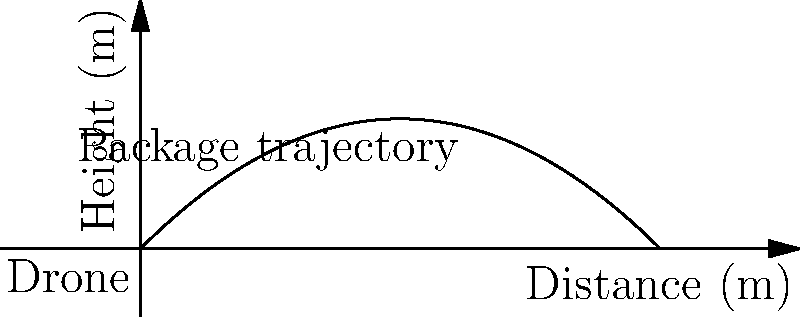A delivery drone launches a package with an initial velocity of 20 m/s at an angle of 45° above the horizontal. Assuming air resistance is negligible, what is the maximum height reached by the package during its flight? To find the maximum height reached by the package, we can follow these steps:

1. Identify the relevant equations:
   - Vertical motion: $y = v_0 \sin(\theta) t - \frac{1}{2}gt^2$
   - Time to reach maximum height: $t_{max} = \frac{v_0 \sin(\theta)}{g}$

2. Given information:
   - Initial velocity: $v_0 = 20$ m/s
   - Launch angle: $\theta = 45°$ (or $\frac{\pi}{4}$ radians)
   - Acceleration due to gravity: $g = 9.8$ m/s²

3. Calculate the time to reach maximum height:
   $t_{max} = \frac{20 \sin(45°)}{9.8} = \frac{20 \cdot \frac{\sqrt{2}}{2}}{9.8} \approx 1.44$ s

4. Use the vertical motion equation to find the maximum height:
   $y_{max} = v_0 \sin(\theta) t_{max} - \frac{1}{2}g(t_{max})^2$

5. Substitute the values:
   $y_{max} = 20 \sin(45°) \cdot 1.44 - \frac{1}{2} \cdot 9.8 \cdot (1.44)^2$
   $y_{max} = 20 \cdot \frac{\sqrt{2}}{2} \cdot 1.44 - \frac{1}{2} \cdot 9.8 \cdot 2.07$
   $y_{max} = 20.4 - 10.14 = 10.26$ m

Therefore, the maximum height reached by the package is approximately 10.26 meters.
Answer: 10.26 m 